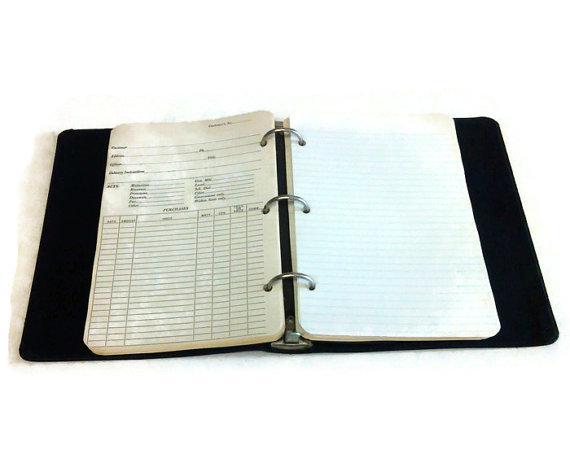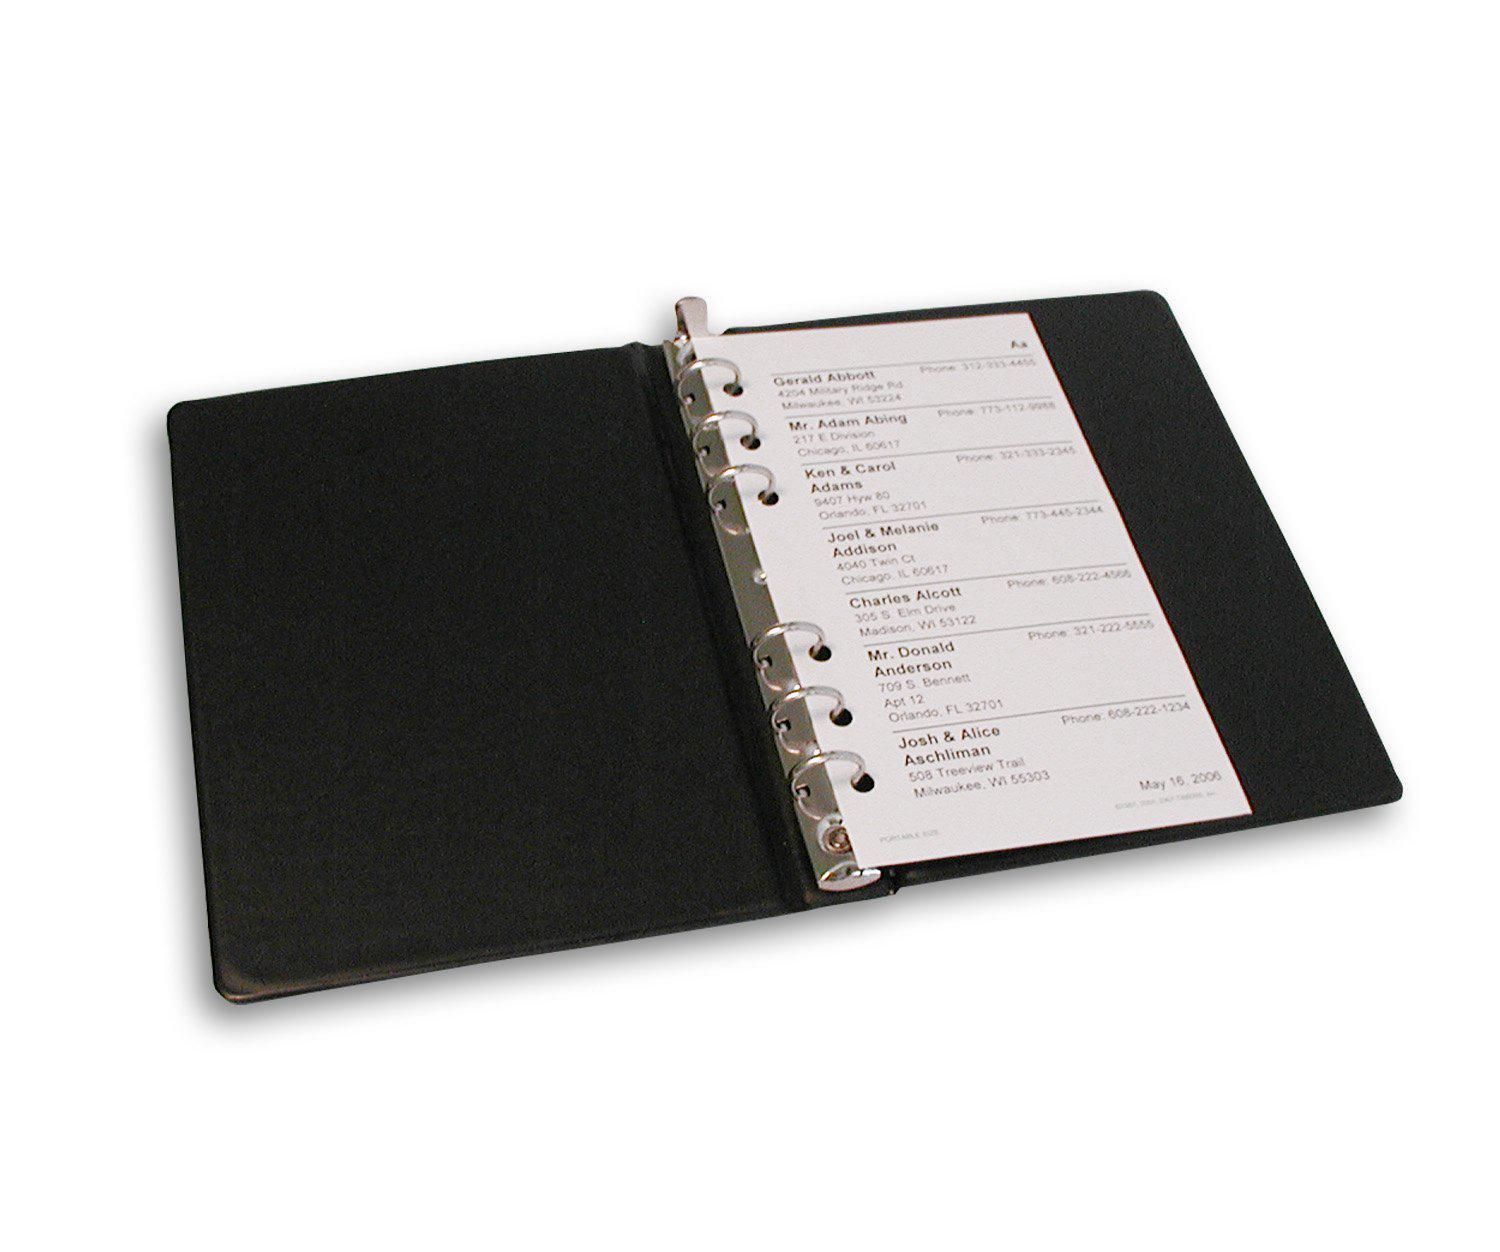The first image is the image on the left, the second image is the image on the right. Examine the images to the left and right. Is the description "Two white notebooks, one open and one closed, are shown in one image, while only one notebook lying flat is in the second image." accurate? Answer yes or no. No. The first image is the image on the left, the second image is the image on the right. For the images displayed, is the sentence "All images show only black binders." factually correct? Answer yes or no. Yes. 